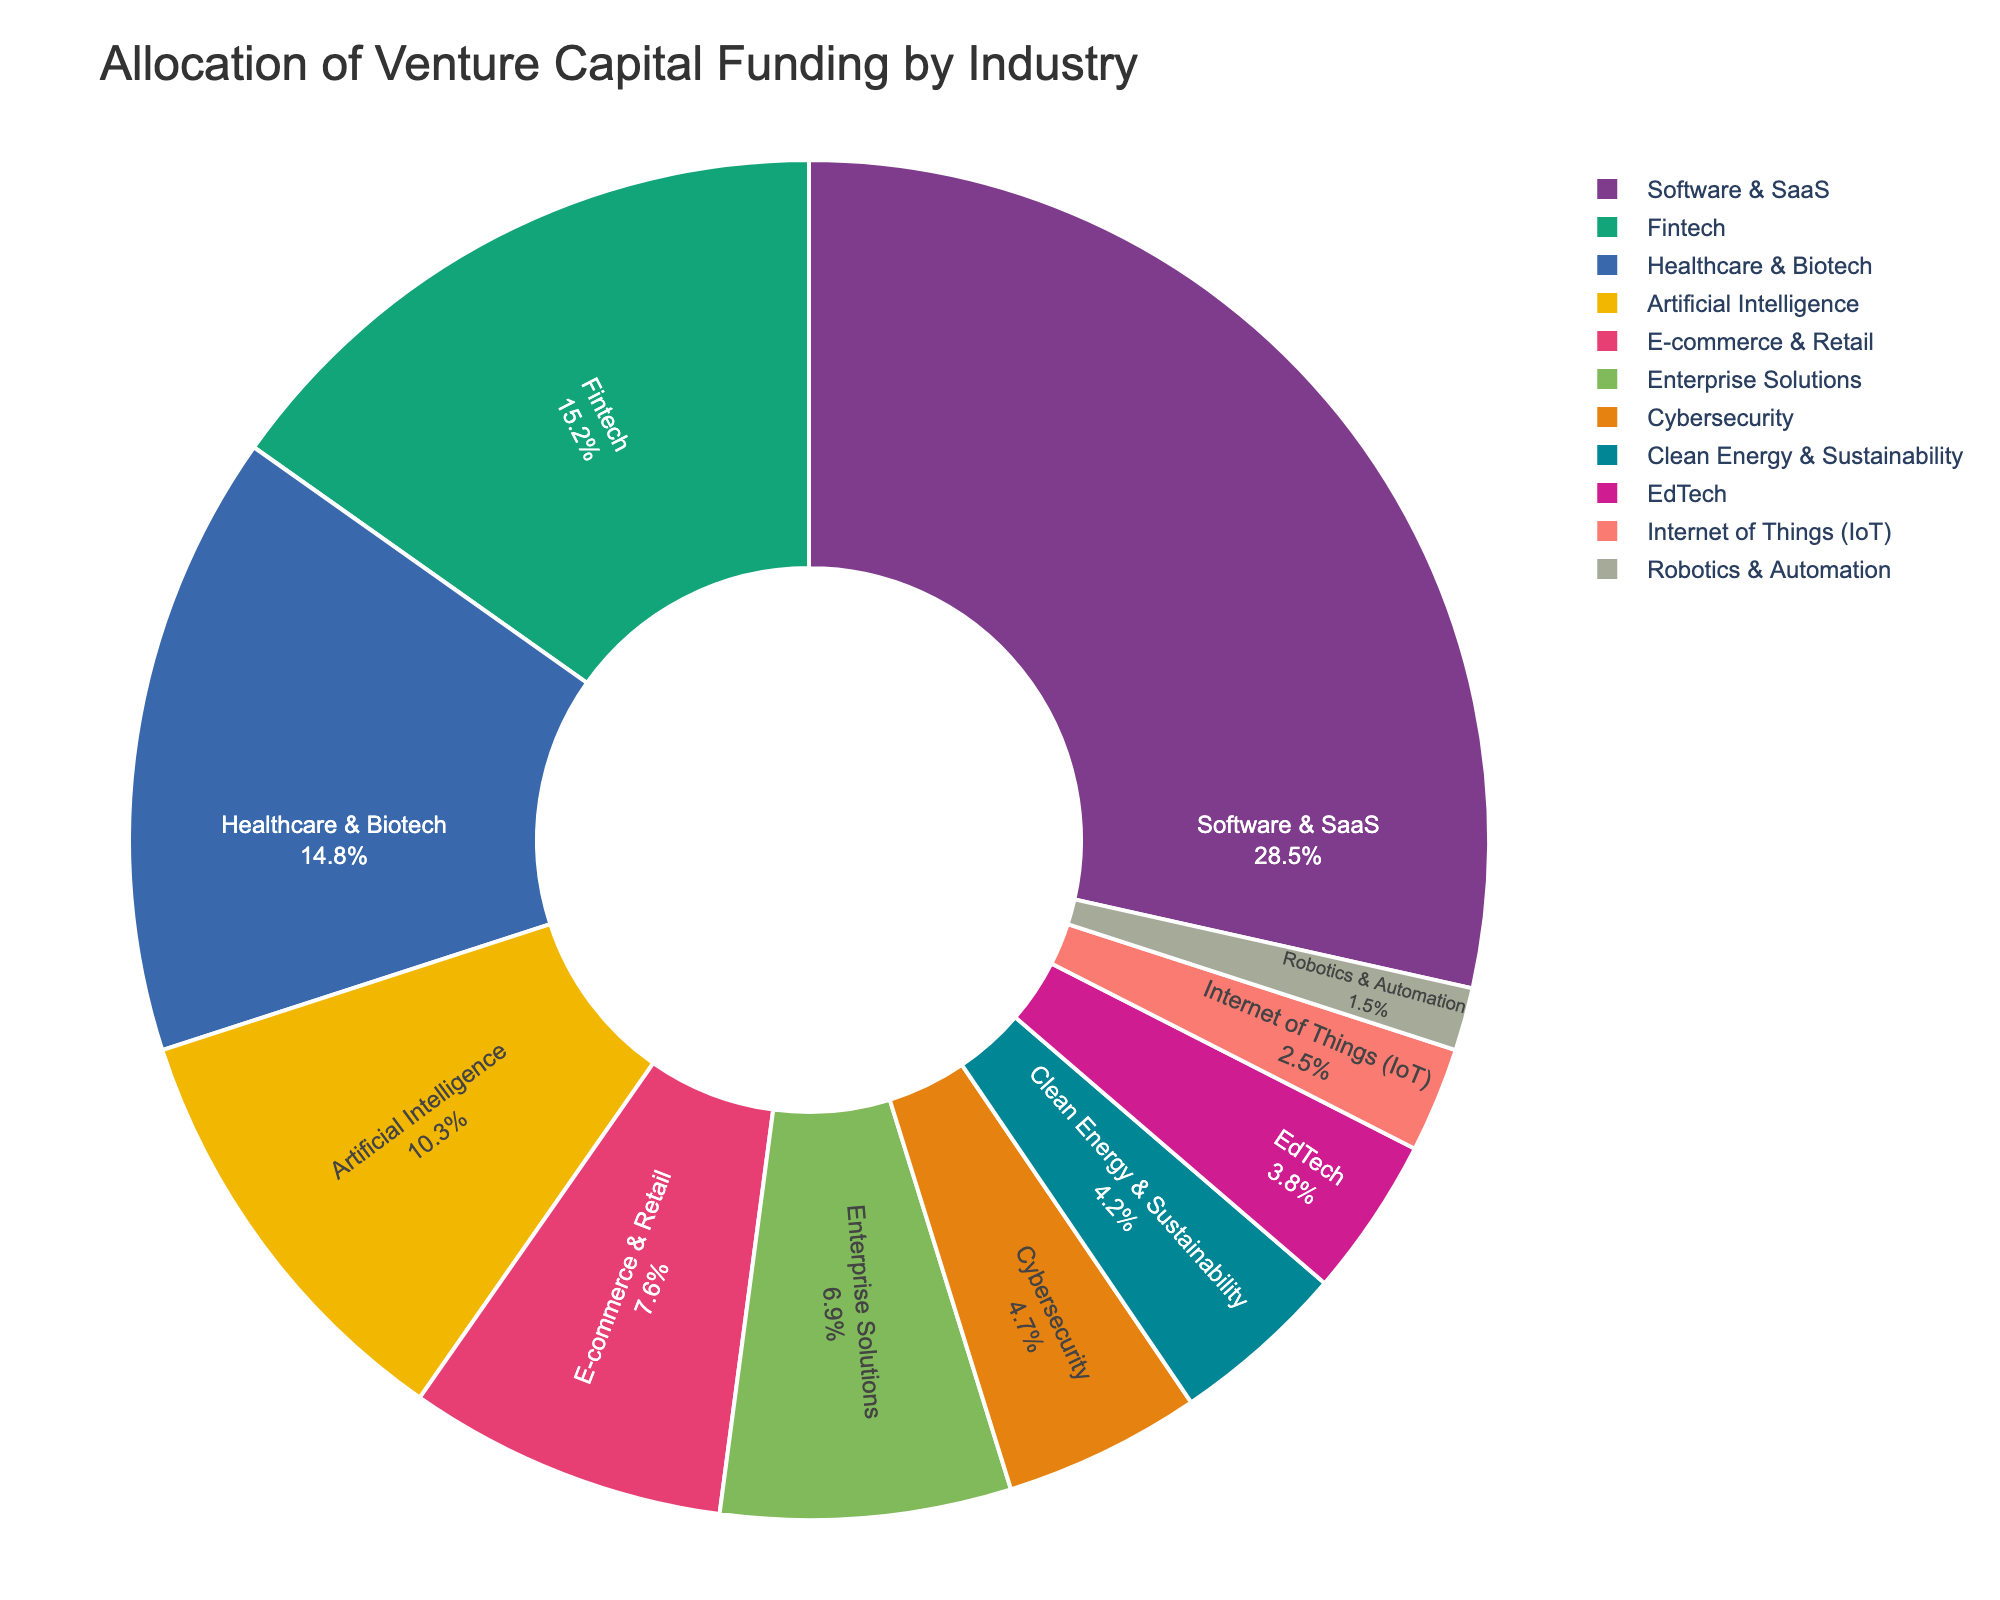Which industry received the highest allocation of venture capital funding? The slice representing the Software & SaaS industry is the largest, so it received the highest allocation.
Answer: Software & SaaS What is the combined percentage of venture capital allocated to Fintech and Healthcare & Biotech? The percentage for Fintech is 15.2% and for Healthcare & Biotech is 14.8%. Adding these percentages gives 15.2 + 14.8 = 30.0%.
Answer: 30.0% How does the funding allocation for Artificial Intelligence compare to that for E-commerce & Retail? The percentage for Artificial Intelligence is 10.3%, while for E-commerce & Retail it is 7.6%. Artificial Intelligence received more funding.
Answer: Artificial Intelligence received more funding Which industries received less than 5% of the venture capital funding? By inspecting the pie chart, industries with slices showing less than 5% are Cybersecurity, Clean Energy & Sustainability, EdTech, Internet of Things (IoT), and Robotics & Automation.
Answer: Cybersecurity, Clean Energy & Sustainability, EdTech, Internet of Things (IoT), Robotics & Automation What is the difference in funding allocation between the largest and smallest industries? The largest industry is Software & SaaS with 28.5%, and the smallest is Robotics & Automation with 1.5%. The difference is 28.5 - 1.5 = 27.0%.
Answer: 27.0% What is the color used for the Fintech industry slice in the pie chart? By observing the pie chart, the color used for the Fintech industry slice should be based on the color sequence from the Bold qualitative palette, typically a distinct color different from others but this detailed visualization description is not specific here. Note that different visualizations may vary so ensure to note the specific color used when checking the exact chart.
Answer: Varies, typically bold color Which industry had a funding allocation close to 10%? The slice representing Artificial Intelligence corresponds to 10.3%, which is close to 10%.
Answer: Artificial Intelligence If the Internet of Things (IoT) and Robotics & Automation were combined, what would their combined percentage be? The IoT received 2.5% and Robotics & Automation received 1.5%. Combined, it is 2.5 + 1.5 = 4.0%.
Answer: 4.0% How does the allocation for EdTech compare to Clean Energy & Sustainability? The percentage for EdTech is 3.8%, and for Clean Energy & Sustainability, it is 4.2%. Clean Energy & Sustainability received slightly more funding.
Answer: Clean Energy & Sustainability received slightly more What percentage of the total funding was allocated to industries other than the top three (Software & SaaS, Fintech, Healthcare & Biotech)? The total percentage for the top three industries is 28.5 + 15.2 + 14.8 = 58.5%. The percentage allocated to other industries is 100 - 58.5 = 41.5%.
Answer: 41.5% 